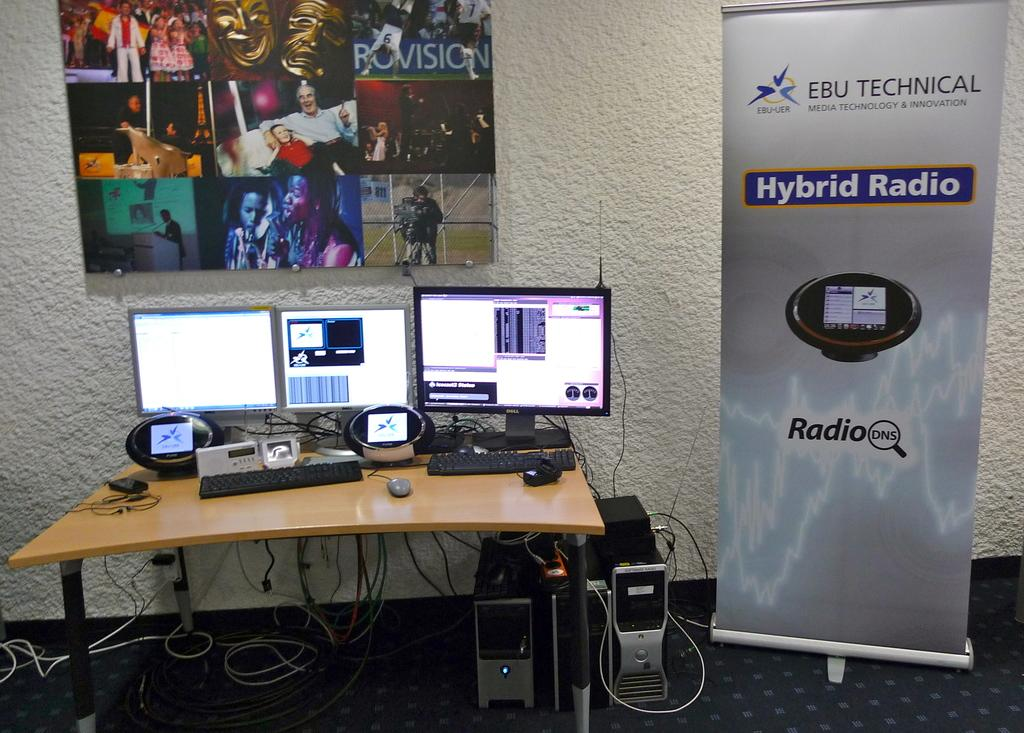<image>
Present a compact description of the photo's key features. a poster next to computer screens that says 'hybrid radio' on it 